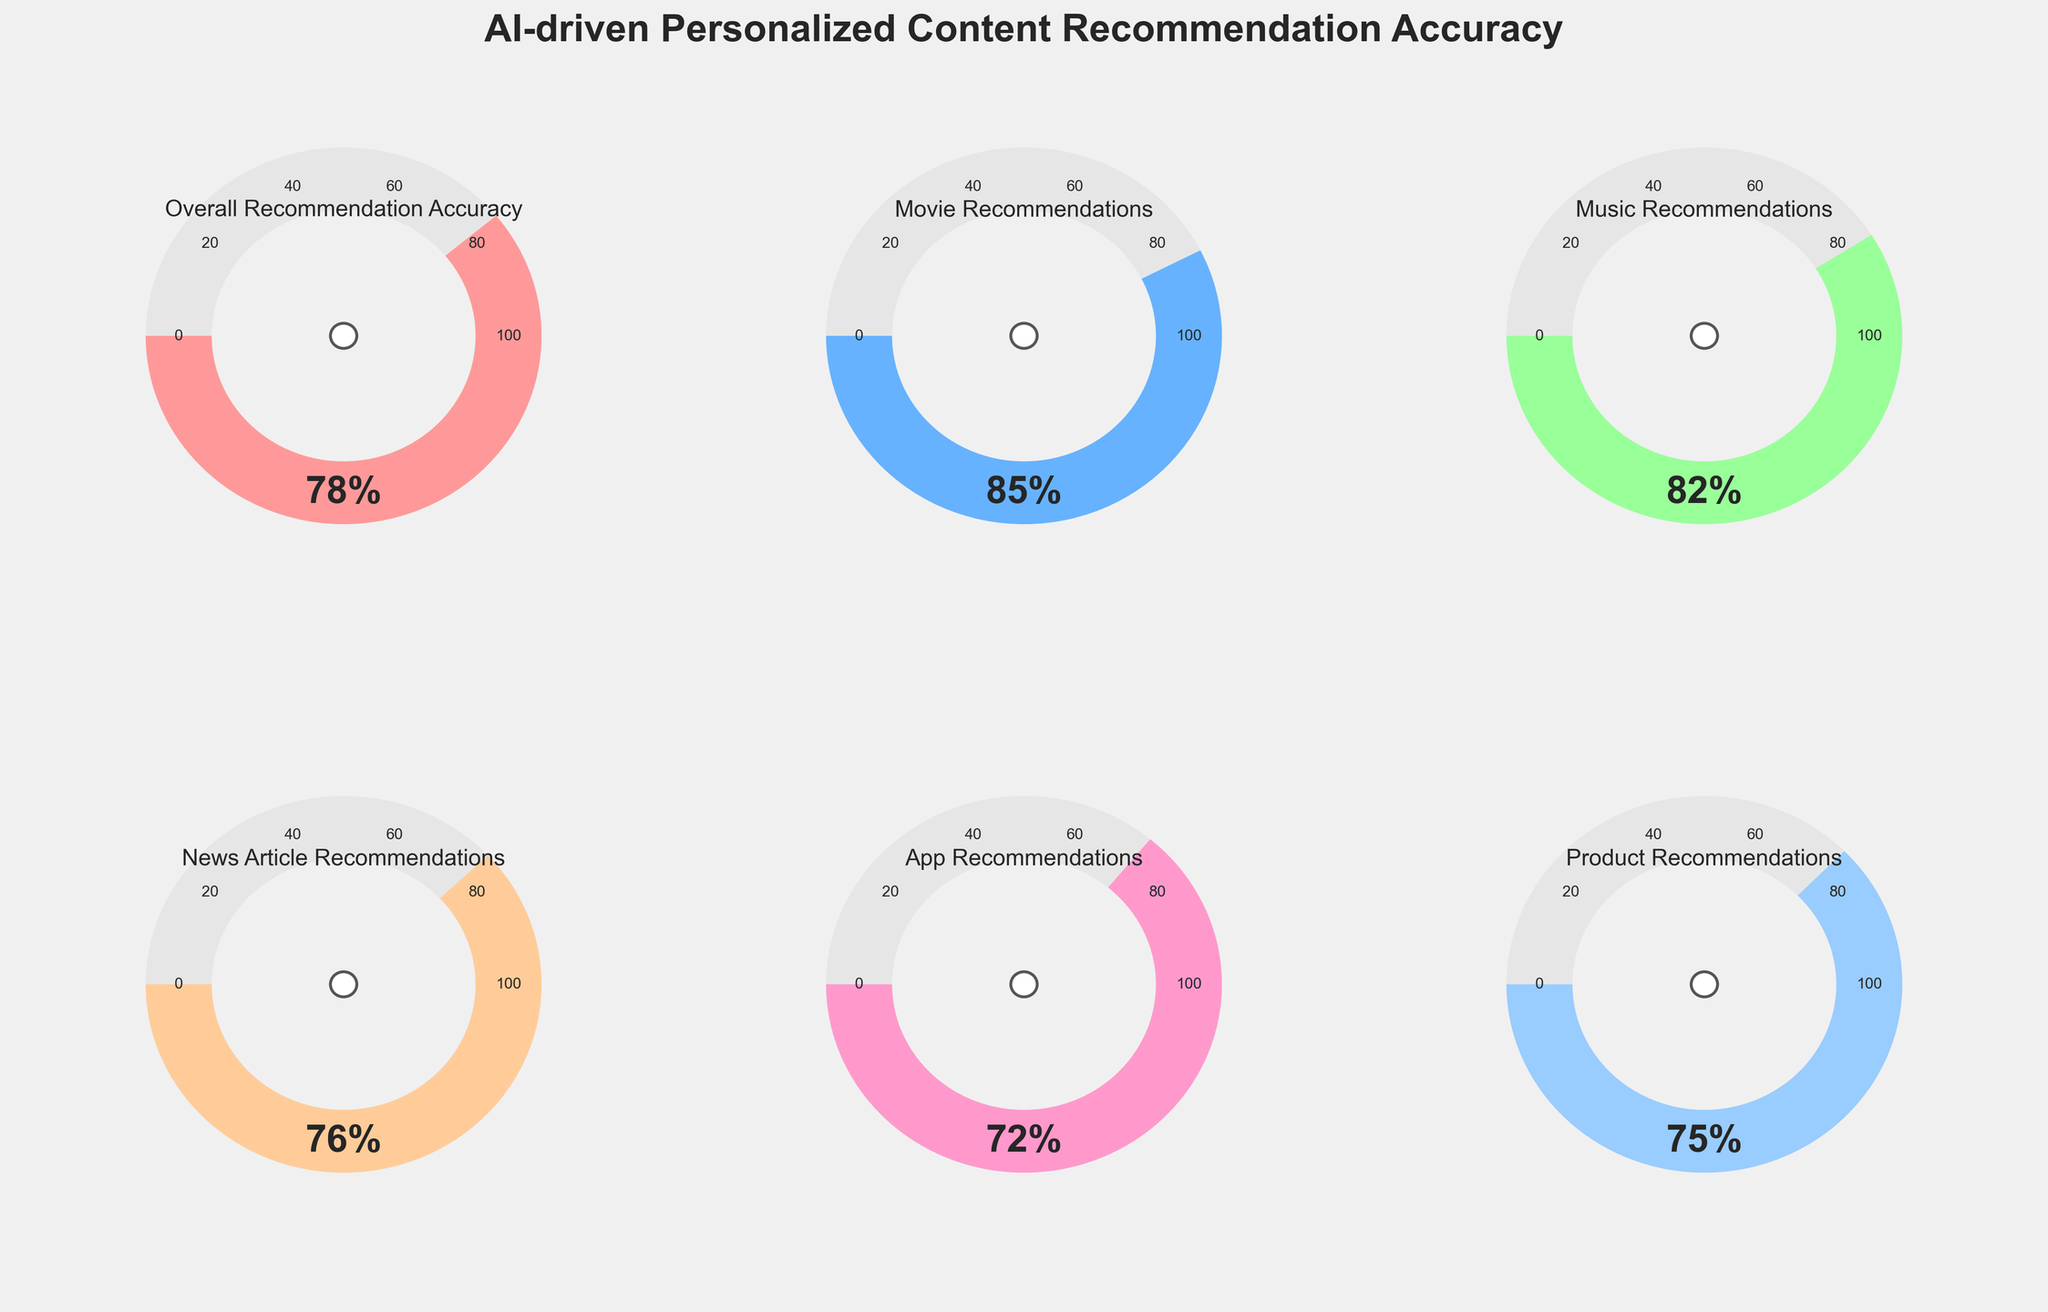Which recommendation category has the highest accuracy? By visual inspection of the gauge charts, the Movie Recommendations category shows the highest value at 85%.
Answer: Movie Recommendations What is the title of the figure? The title is prominently displayed at the top of the figure, reading "AI-driven Personalized Content Recommendation Accuracy".
Answer: AI-driven Personalized Content Recommendation Accuracy Which recommendation category has the lowest accuracy? By visual inspection of the gauge charts, the App Recommendations category shows the lowest value at 72%.
Answer: App Recommendations What is the overall recommendation accuracy percentage? The gauge chart labeled "Overall Recommendation Accuracy" displays a percentage value of 78%.
Answer: 78% How does the accuracy of Movie Recommendations compare to the accuracy of Product Recommendations? Movie Recommendations’ accuracy is 85%, while Product Recommendations’ accuracy is 75%. Therefore, Movie Recommendations have a 10 percentage points higher accuracy than Product Recommendations.
Answer: 10 percentage points higher Which categories have an accuracy above 80%? By visual inspection, both Movie Recommendations (85%) and Music Recommendations (82%) have accuracies above 80%.
Answer: Movie Recommendations, Music Recommendations How much lower is the accuracy of News Article Recommendations compared to Music Recommendations? News Article Recommendations have an accuracy of 76% and Music Recommendations have an accuracy of 82%. The difference is calculated as 82% - 76% = 6%.
Answer: 6% What are the minimum and maximum values of the gauges used in the figure? All gauge charts in the figure follow a scale with a minimum value of 0 and a maximum value of 100 as seen by the tick marks on the gauge edges.
Answer: 0 and 100 What color is used to represent the Product Recommendations gauge? The Product Recommendations gauge is represented using a light blue color.
Answer: light blue 